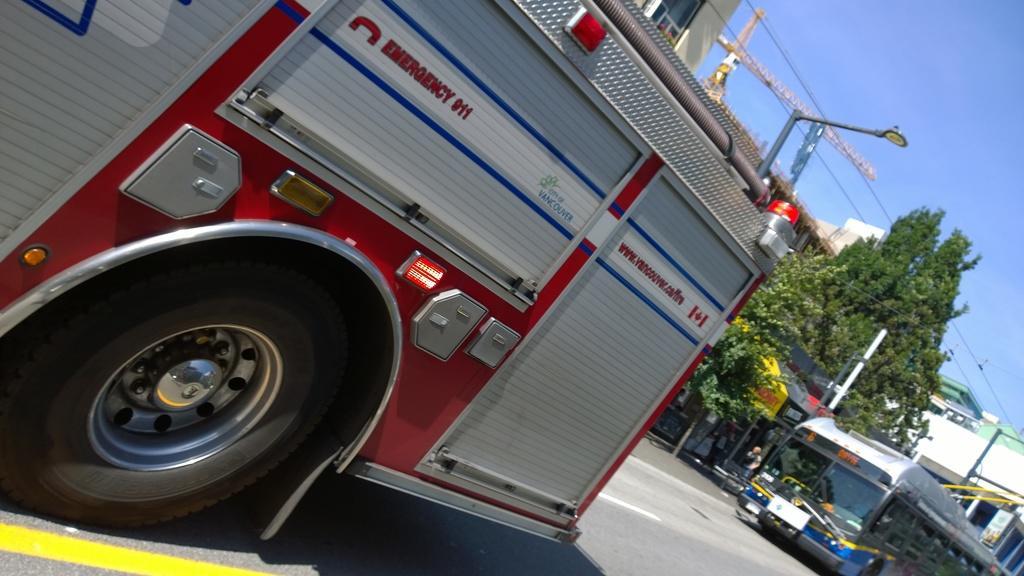Please provide a concise description of this image. In this picture we can see vehicles on the road, trees, buildings, wires, pole and some persons standing and in the background we can see sky. 